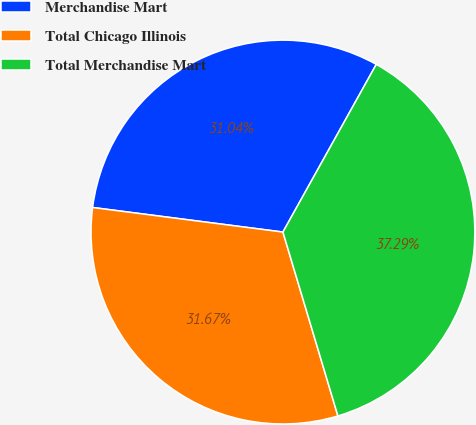<chart> <loc_0><loc_0><loc_500><loc_500><pie_chart><fcel>Merchandise Mart<fcel>Total Chicago Illinois<fcel>Total Merchandise Mart<nl><fcel>31.04%<fcel>31.67%<fcel>37.29%<nl></chart> 